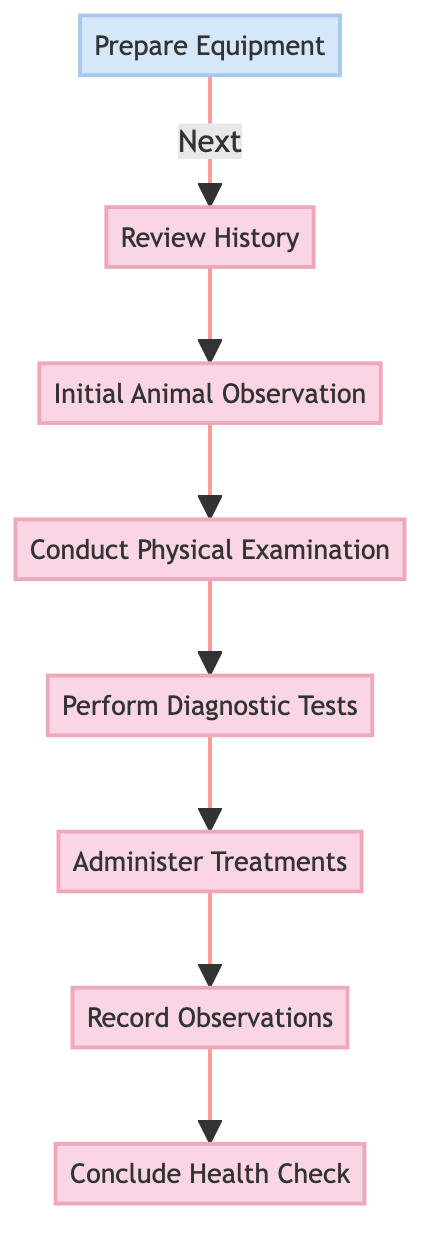What is the first step in the procedure? The diagram indicates that the first step in the procedure is "Prepare Equipment," which is the initial node in the flow of the process.
Answer: Prepare Equipment How many total steps or nodes are in the diagram? The diagram consists of eight nodes, including both preparation and process nodes.
Answer: Eight What follows after "Initial Animal Observation"? The diagram shows that "Conduct Physical Examination" follows directly after "Initial Animal Observation," indicating the next step in the procedure.
Answer: Conduct Physical Examination What is the last step in the health check process? According to the diagram, the last step in the health check process is "Conclude Health Check," which is the final node at the top of the flow.
Answer: Conclude Health Check Which step comes immediately after "Administer Treatments"? The sequence in the diagram indicates that "Record Observations" comes immediately after "Administer Treatments," showing the flow of information.
Answer: Record Observations How are the nodes linked together in the diagram? The nodes in the diagram are linked sequentially, where each step flows into the next, forming a clear linear path from preparation to conclusion.
Answer: Sequentially What type of node is "Prepare Equipment"? In the diagram, "Prepare Equipment" is classified as a "Preparation" node, highlighting its role before the main processes begin.
Answer: Preparation Which node directly precedes "Perform Diagnostic Tests"? The diagram indicates that "Conduct Physical Examination" directly precedes "Perform Diagnostic Tests," making it the immediate prior step.
Answer: Conduct Physical Examination What type of process is "Conclude Health Check"? "Conclude Health Check" is categorized as a "Process" type node, as it summarizes findings and determines next steps.
Answer: Process 